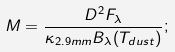<formula> <loc_0><loc_0><loc_500><loc_500>M = \frac { D ^ { 2 } F _ { \lambda } } { \kappa _ { 2 . 9 m m } B _ { \lambda } ( T _ { d u s t } ) } ;</formula> 